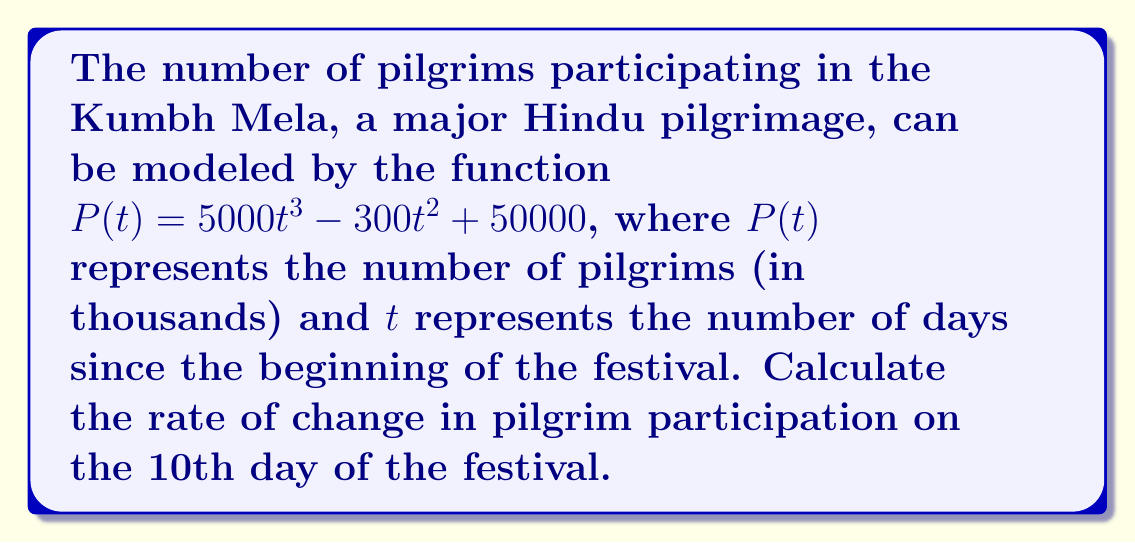What is the answer to this math problem? To find the rate of change in pilgrim participation on the 10th day, we need to calculate the derivative of $P(t)$ and evaluate it at $t=10$.

1. First, let's find the derivative of $P(t)$:
   $$P'(t) = \frac{d}{dt}(5000t^3 - 300t^2 + 50000)$$
   $$P'(t) = 15000t^2 - 600t$$

2. Now, we evaluate $P'(t)$ at $t=10$:
   $$P'(10) = 15000(10)^2 - 600(10)$$
   $$P'(10) = 15000(100) - 6000$$
   $$P'(10) = 1500000 - 6000$$
   $$P'(10) = 1494000$$

3. Interpret the result:
   The rate of change is 1,494,000 thousand pilgrims per day, which is equivalent to 1,494,000,000 pilgrims per day.

This rapid growth rate reflects the massive influx of devotees during the Kumbh Mela, symbolizing the fervor and spiritual significance of this Bhakti movement-inspired gathering.
Answer: 1,494,000,000 pilgrims/day 